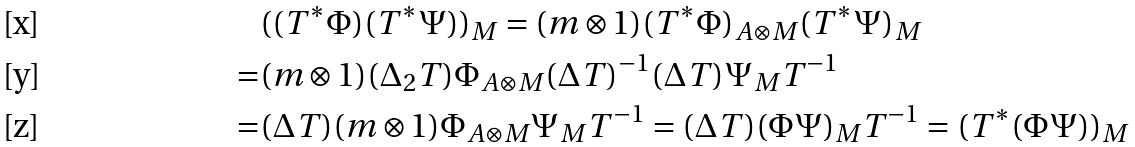Convert formula to latex. <formula><loc_0><loc_0><loc_500><loc_500>& ( ( T ^ { * } \Phi ) ( T ^ { * } \Psi ) ) _ { M } = ( m \otimes 1 ) ( T ^ { * } \Phi ) _ { A \otimes M } ( T ^ { * } \Psi ) _ { M } \\ = & ( m \otimes 1 ) ( \Delta _ { 2 } T ) \Phi _ { A \otimes M } ( \Delta T ) ^ { - 1 } ( \Delta T ) \Psi _ { M } T ^ { - 1 } \\ = & ( \Delta T ) ( m \otimes 1 ) \Phi _ { A \otimes M } \Psi _ { M } T ^ { - 1 } = ( \Delta T ) ( \Phi \Psi ) _ { M } T ^ { - 1 } = ( T ^ { * } ( \Phi \Psi ) ) _ { M }</formula> 